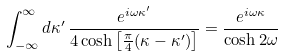<formula> <loc_0><loc_0><loc_500><loc_500>\int _ { - \infty } ^ { \infty } d \kappa ^ { \prime } \, \frac { e ^ { i \omega \kappa ^ { \prime } } } { 4 \cosh \left [ \frac { \pi } { 4 } ( \kappa - \kappa ^ { \prime } ) \right ] } = \frac { e ^ { i \omega \kappa } } { \cosh 2 \omega }</formula> 